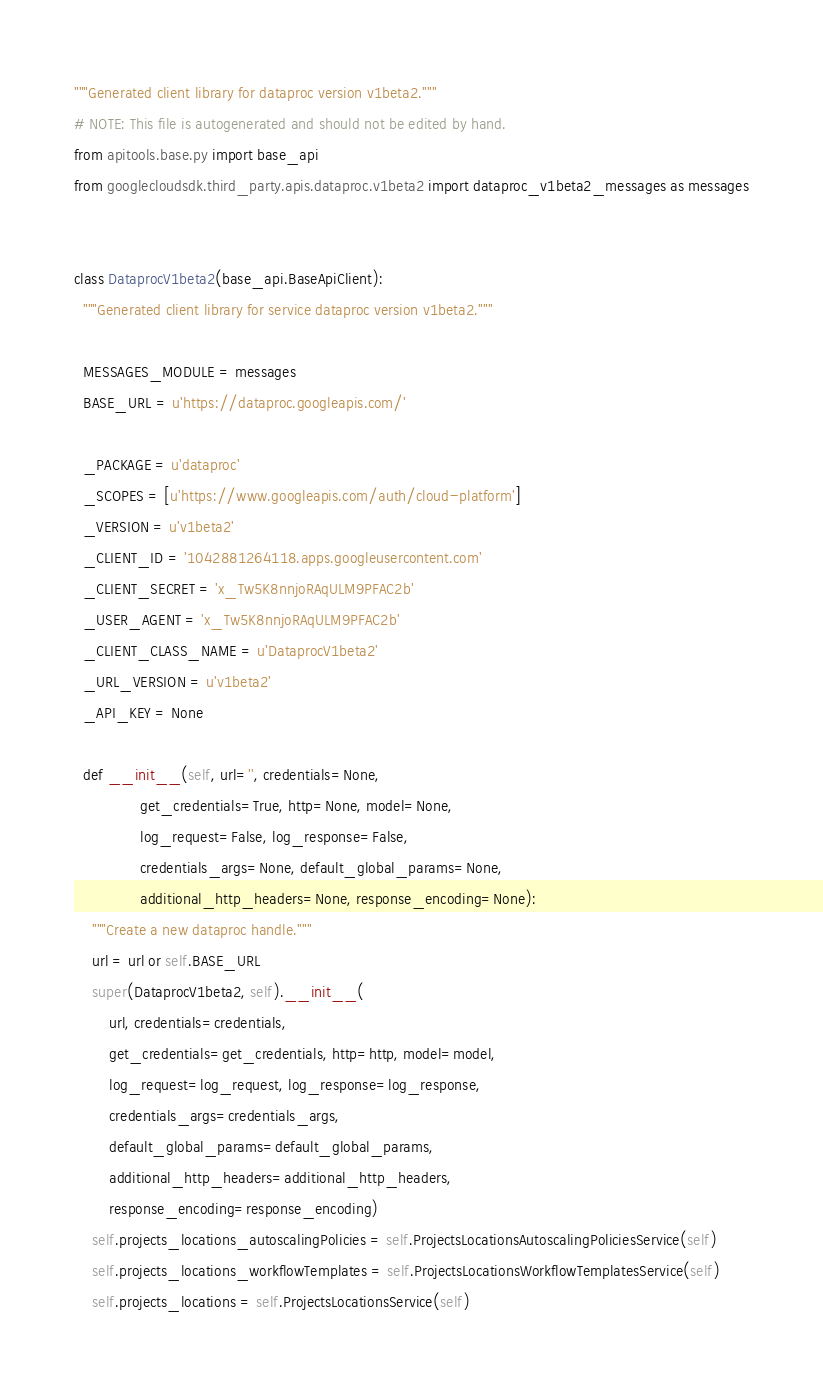<code> <loc_0><loc_0><loc_500><loc_500><_Python_>"""Generated client library for dataproc version v1beta2."""
# NOTE: This file is autogenerated and should not be edited by hand.
from apitools.base.py import base_api
from googlecloudsdk.third_party.apis.dataproc.v1beta2 import dataproc_v1beta2_messages as messages


class DataprocV1beta2(base_api.BaseApiClient):
  """Generated client library for service dataproc version v1beta2."""

  MESSAGES_MODULE = messages
  BASE_URL = u'https://dataproc.googleapis.com/'

  _PACKAGE = u'dataproc'
  _SCOPES = [u'https://www.googleapis.com/auth/cloud-platform']
  _VERSION = u'v1beta2'
  _CLIENT_ID = '1042881264118.apps.googleusercontent.com'
  _CLIENT_SECRET = 'x_Tw5K8nnjoRAqULM9PFAC2b'
  _USER_AGENT = 'x_Tw5K8nnjoRAqULM9PFAC2b'
  _CLIENT_CLASS_NAME = u'DataprocV1beta2'
  _URL_VERSION = u'v1beta2'
  _API_KEY = None

  def __init__(self, url='', credentials=None,
               get_credentials=True, http=None, model=None,
               log_request=False, log_response=False,
               credentials_args=None, default_global_params=None,
               additional_http_headers=None, response_encoding=None):
    """Create a new dataproc handle."""
    url = url or self.BASE_URL
    super(DataprocV1beta2, self).__init__(
        url, credentials=credentials,
        get_credentials=get_credentials, http=http, model=model,
        log_request=log_request, log_response=log_response,
        credentials_args=credentials_args,
        default_global_params=default_global_params,
        additional_http_headers=additional_http_headers,
        response_encoding=response_encoding)
    self.projects_locations_autoscalingPolicies = self.ProjectsLocationsAutoscalingPoliciesService(self)
    self.projects_locations_workflowTemplates = self.ProjectsLocationsWorkflowTemplatesService(self)
    self.projects_locations = self.ProjectsLocationsService(self)</code> 